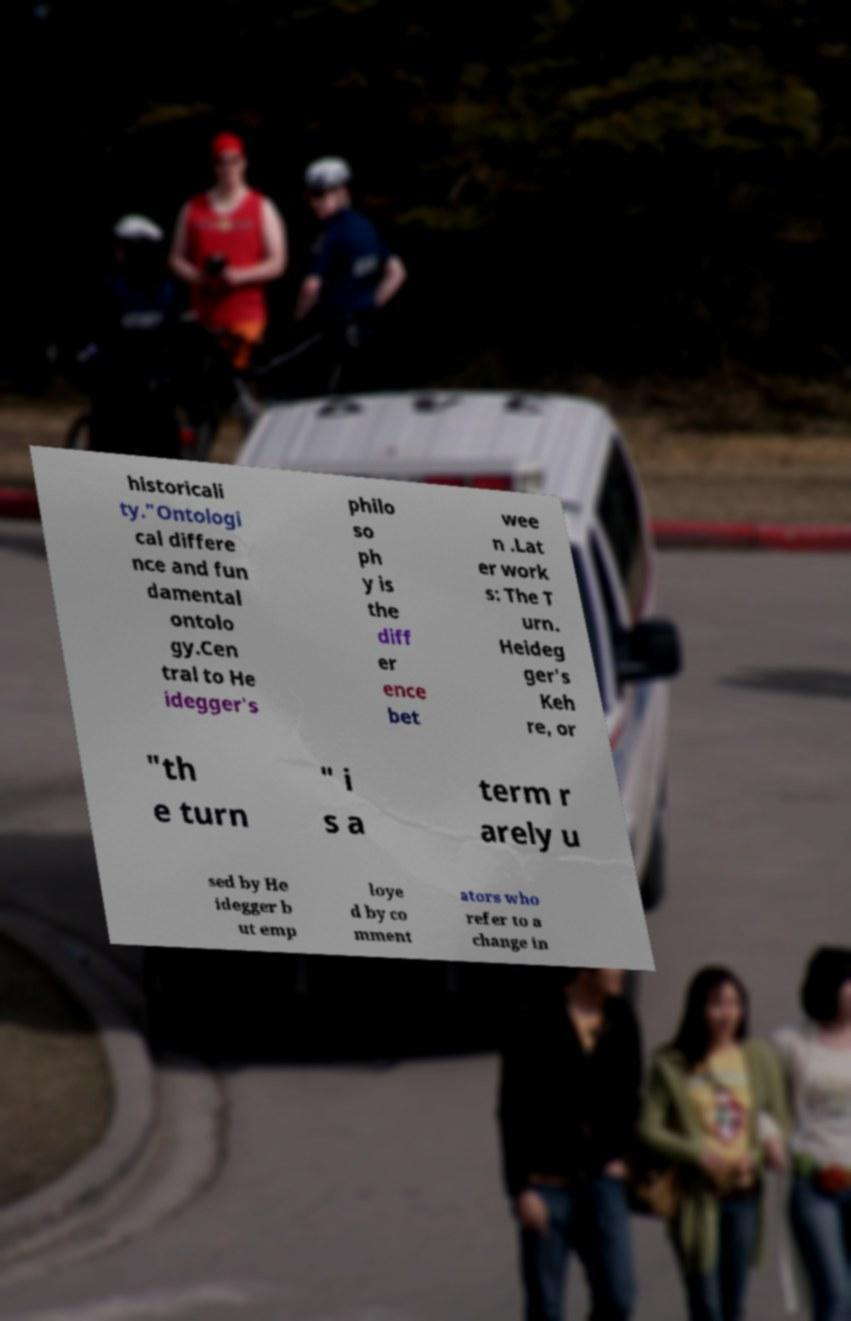Please identify and transcribe the text found in this image. historicali ty."Ontologi cal differe nce and fun damental ontolo gy.Cen tral to He idegger's philo so ph y is the diff er ence bet wee n .Lat er work s: The T urn. Heideg ger's Keh re, or "th e turn " i s a term r arely u sed by He idegger b ut emp loye d by co mment ators who refer to a change in 